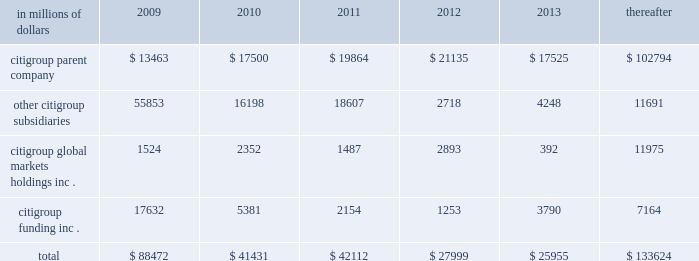Cgmhi also has substantial borrowing arrangements consisting of facilities that cgmhi has been advised are available , but where no contractual lending obligation exists .
These arrangements are reviewed on an ongoing basis to ensure flexibility in meeting cgmhi 2019s short-term requirements .
The company issues both fixed and variable rate debt in a range of currencies .
It uses derivative contracts , primarily interest rate swaps , to effectively convert a portion of its fixed rate debt to variable rate debt and variable rate debt to fixed rate debt .
The maturity structure of the derivatives generally corresponds to the maturity structure of the debt being hedged .
In addition , the company uses other derivative contracts to manage the foreign exchange impact of certain debt issuances .
At december 31 , 2008 , the company 2019s overall weighted average interest rate for long-term debt was 3.83% ( 3.83 % ) on a contractual basis and 4.19% ( 4.19 % ) including the effects of derivative contracts .
Aggregate annual maturities of long-term debt obligations ( based on final maturity dates ) including trust preferred securities are as follows : in millions of dollars 2009 2010 2011 2012 2013 thereafter .
Long-term debt at december 31 , 2008 and december 31 , 2007 includes $ 24060 million and $ 23756 million , respectively , of junior subordinated debt .
The company formed statutory business trusts under the laws of the state of delaware .
The trusts exist for the exclusive purposes of ( i ) issuing trust securities representing undivided beneficial interests in the assets of the trust ; ( ii ) investing the gross proceeds of the trust securities in junior subordinated deferrable interest debentures ( subordinated debentures ) of its parent ; and ( iii ) engaging in only those activities necessary or incidental thereto .
Upon approval from the federal reserve , citigroup has the right to redeem these securities .
Citigroup has contractually agreed not to redeem or purchase ( i ) the 6.50% ( 6.50 % ) enhanced trust preferred securities of citigroup capital xv before september 15 , 2056 , ( ii ) the 6.45% ( 6.45 % ) enhanced trust preferred securities of citigroup capital xvi before december 31 , 2046 , ( iii ) the 6.35% ( 6.35 % ) enhanced trust preferred securities of citigroup capital xvii before march 15 , 2057 , ( iv ) the 6.829% ( 6.829 % ) fixed rate/floating rate enhanced trust preferred securities of citigroup capital xviii before june 28 , 2047 , ( v ) the 7.250% ( 7.250 % ) enhanced trust preferred securities of citigroup capital xix before august 15 , 2047 , ( vi ) the 7.875% ( 7.875 % ) enhanced trust preferred securities of citigroup capital xx before december 15 , 2067 , and ( vii ) the 8.300% ( 8.300 % ) fixed rate/floating rate enhanced trust preferred securities of citigroup capital xxi before december 21 , 2067 unless certain conditions , described in exhibit 4.03 to citigroup 2019s current report on form 8-k filed on september 18 , 2006 , in exhibit 4.02 to citigroup 2019s current report on form 8-k filed on november 28 , 2006 , in exhibit 4.02 to citigroup 2019s current report on form 8-k filed on march 8 , 2007 , in exhibit 4.02 to citigroup 2019s current report on form 8-k filed on july 2 , 2007 , in exhibit 4.02 to citigroup 2019s current report on form 8-k filed on august 17 , 2007 , in exhibit 4.2 to citigroup 2019s current report on form 8-k filed on november 27 , 2007 , and in exhibit 4.2 to citigroup 2019s current report on form 8-k filed on december 21 , 2007 , respectively , are met .
These agreements are for the benefit of the holders of citigroup 2019s 6.00% ( 6.00 % ) junior subordinated deferrable interest debentures due 2034 .
Citigroup owns all of the voting securities of these subsidiary trusts .
These subsidiary trusts have no assets , operations , revenues or cash flows other than those related to the issuance , administration and repayment of the subsidiary trusts and the subsidiary trusts 2019 common securities .
These subsidiary trusts 2019 obligations are fully and unconditionally guaranteed by citigroup. .
What percentage of total aggregate annual maturities of long-term debt obligations ( based on final maturity dates ) including trust preferred securities due in 2010 are related to citigroup funding inc . ? 
Computations: (5381 / 41431)
Answer: 0.12988. 